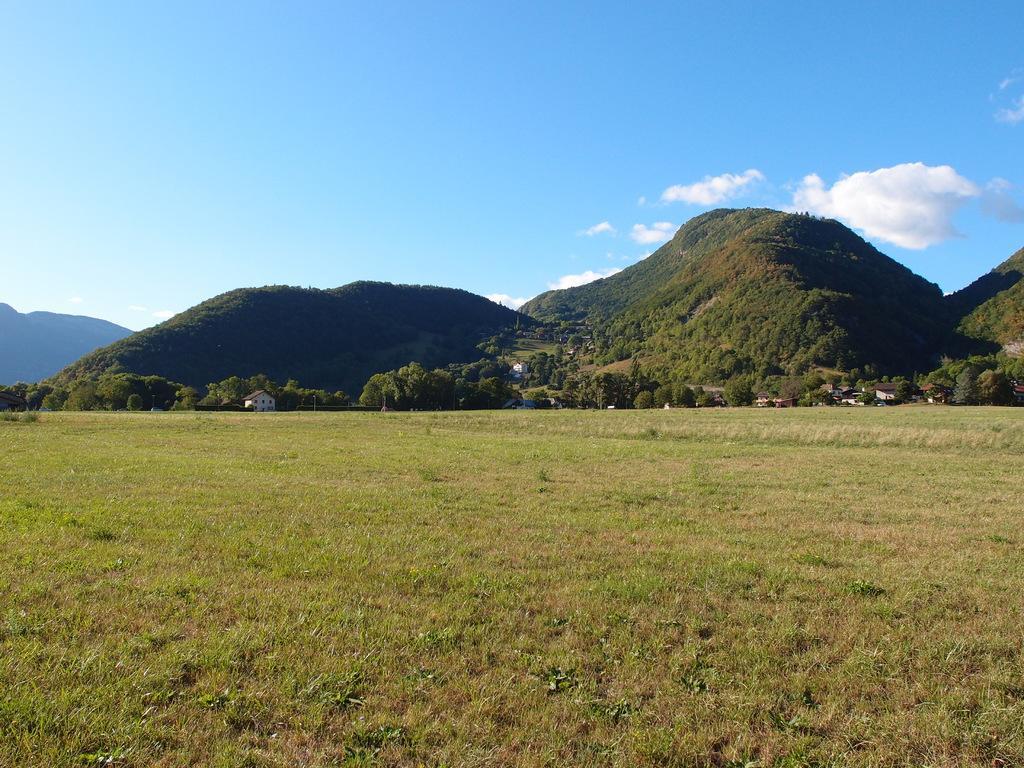How would you summarize this image in a sentence or two? In this image we can see grassy land. In the middle of the image mountains are there. On mountain trees and houses are there. Top of the image sky is there with some clouds. 